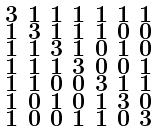<formula> <loc_0><loc_0><loc_500><loc_500>\begin{smallmatrix} 3 & 1 & 1 & 1 & 1 & 1 & 1 \\ 1 & 3 & 1 & 1 & 1 & 0 & 0 \\ 1 & 1 & 3 & 1 & 0 & 1 & 0 \\ 1 & 1 & 1 & 3 & 0 & 0 & 1 \\ 1 & 1 & 0 & 0 & 3 & 1 & 1 \\ 1 & 0 & 1 & 0 & 1 & 3 & 0 \\ 1 & 0 & 0 & 1 & 1 & 0 & 3 \end{smallmatrix}</formula> 